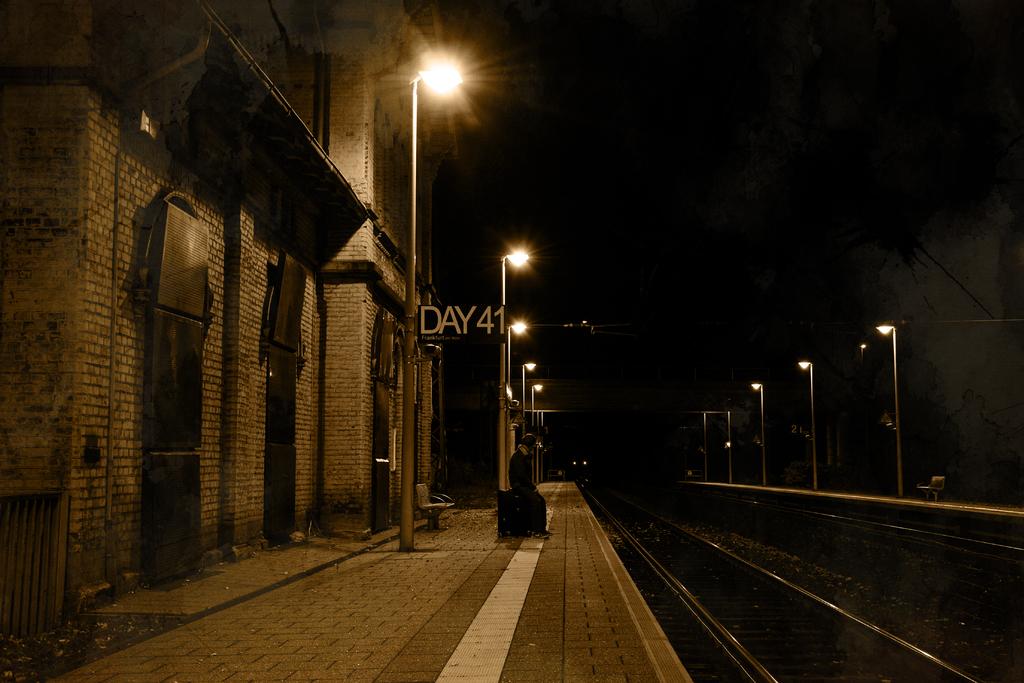What day number is mentioned?
Provide a short and direct response. 41. What word is depicted before the number?
Give a very brief answer. Day. 